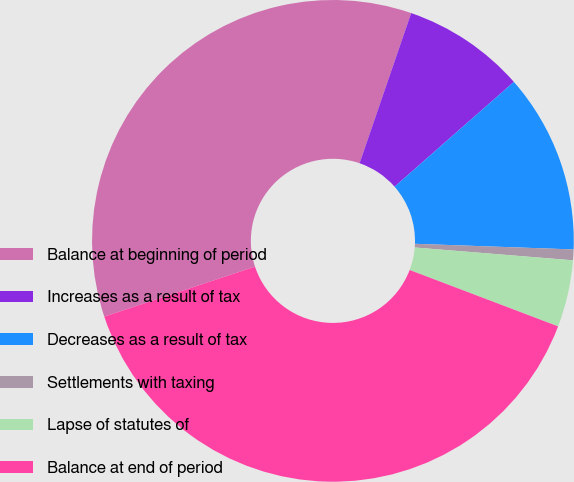Convert chart. <chart><loc_0><loc_0><loc_500><loc_500><pie_chart><fcel>Balance at beginning of period<fcel>Increases as a result of tax<fcel>Decreases as a result of tax<fcel>Settlements with taxing<fcel>Lapse of statutes of<fcel>Balance at end of period<nl><fcel>35.36%<fcel>8.26%<fcel>12.04%<fcel>0.72%<fcel>4.49%<fcel>39.13%<nl></chart> 